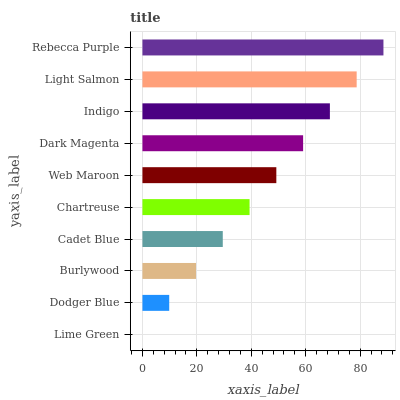Is Lime Green the minimum?
Answer yes or no. Yes. Is Rebecca Purple the maximum?
Answer yes or no. Yes. Is Dodger Blue the minimum?
Answer yes or no. No. Is Dodger Blue the maximum?
Answer yes or no. No. Is Dodger Blue greater than Lime Green?
Answer yes or no. Yes. Is Lime Green less than Dodger Blue?
Answer yes or no. Yes. Is Lime Green greater than Dodger Blue?
Answer yes or no. No. Is Dodger Blue less than Lime Green?
Answer yes or no. No. Is Web Maroon the high median?
Answer yes or no. Yes. Is Chartreuse the low median?
Answer yes or no. Yes. Is Lime Green the high median?
Answer yes or no. No. Is Dark Magenta the low median?
Answer yes or no. No. 